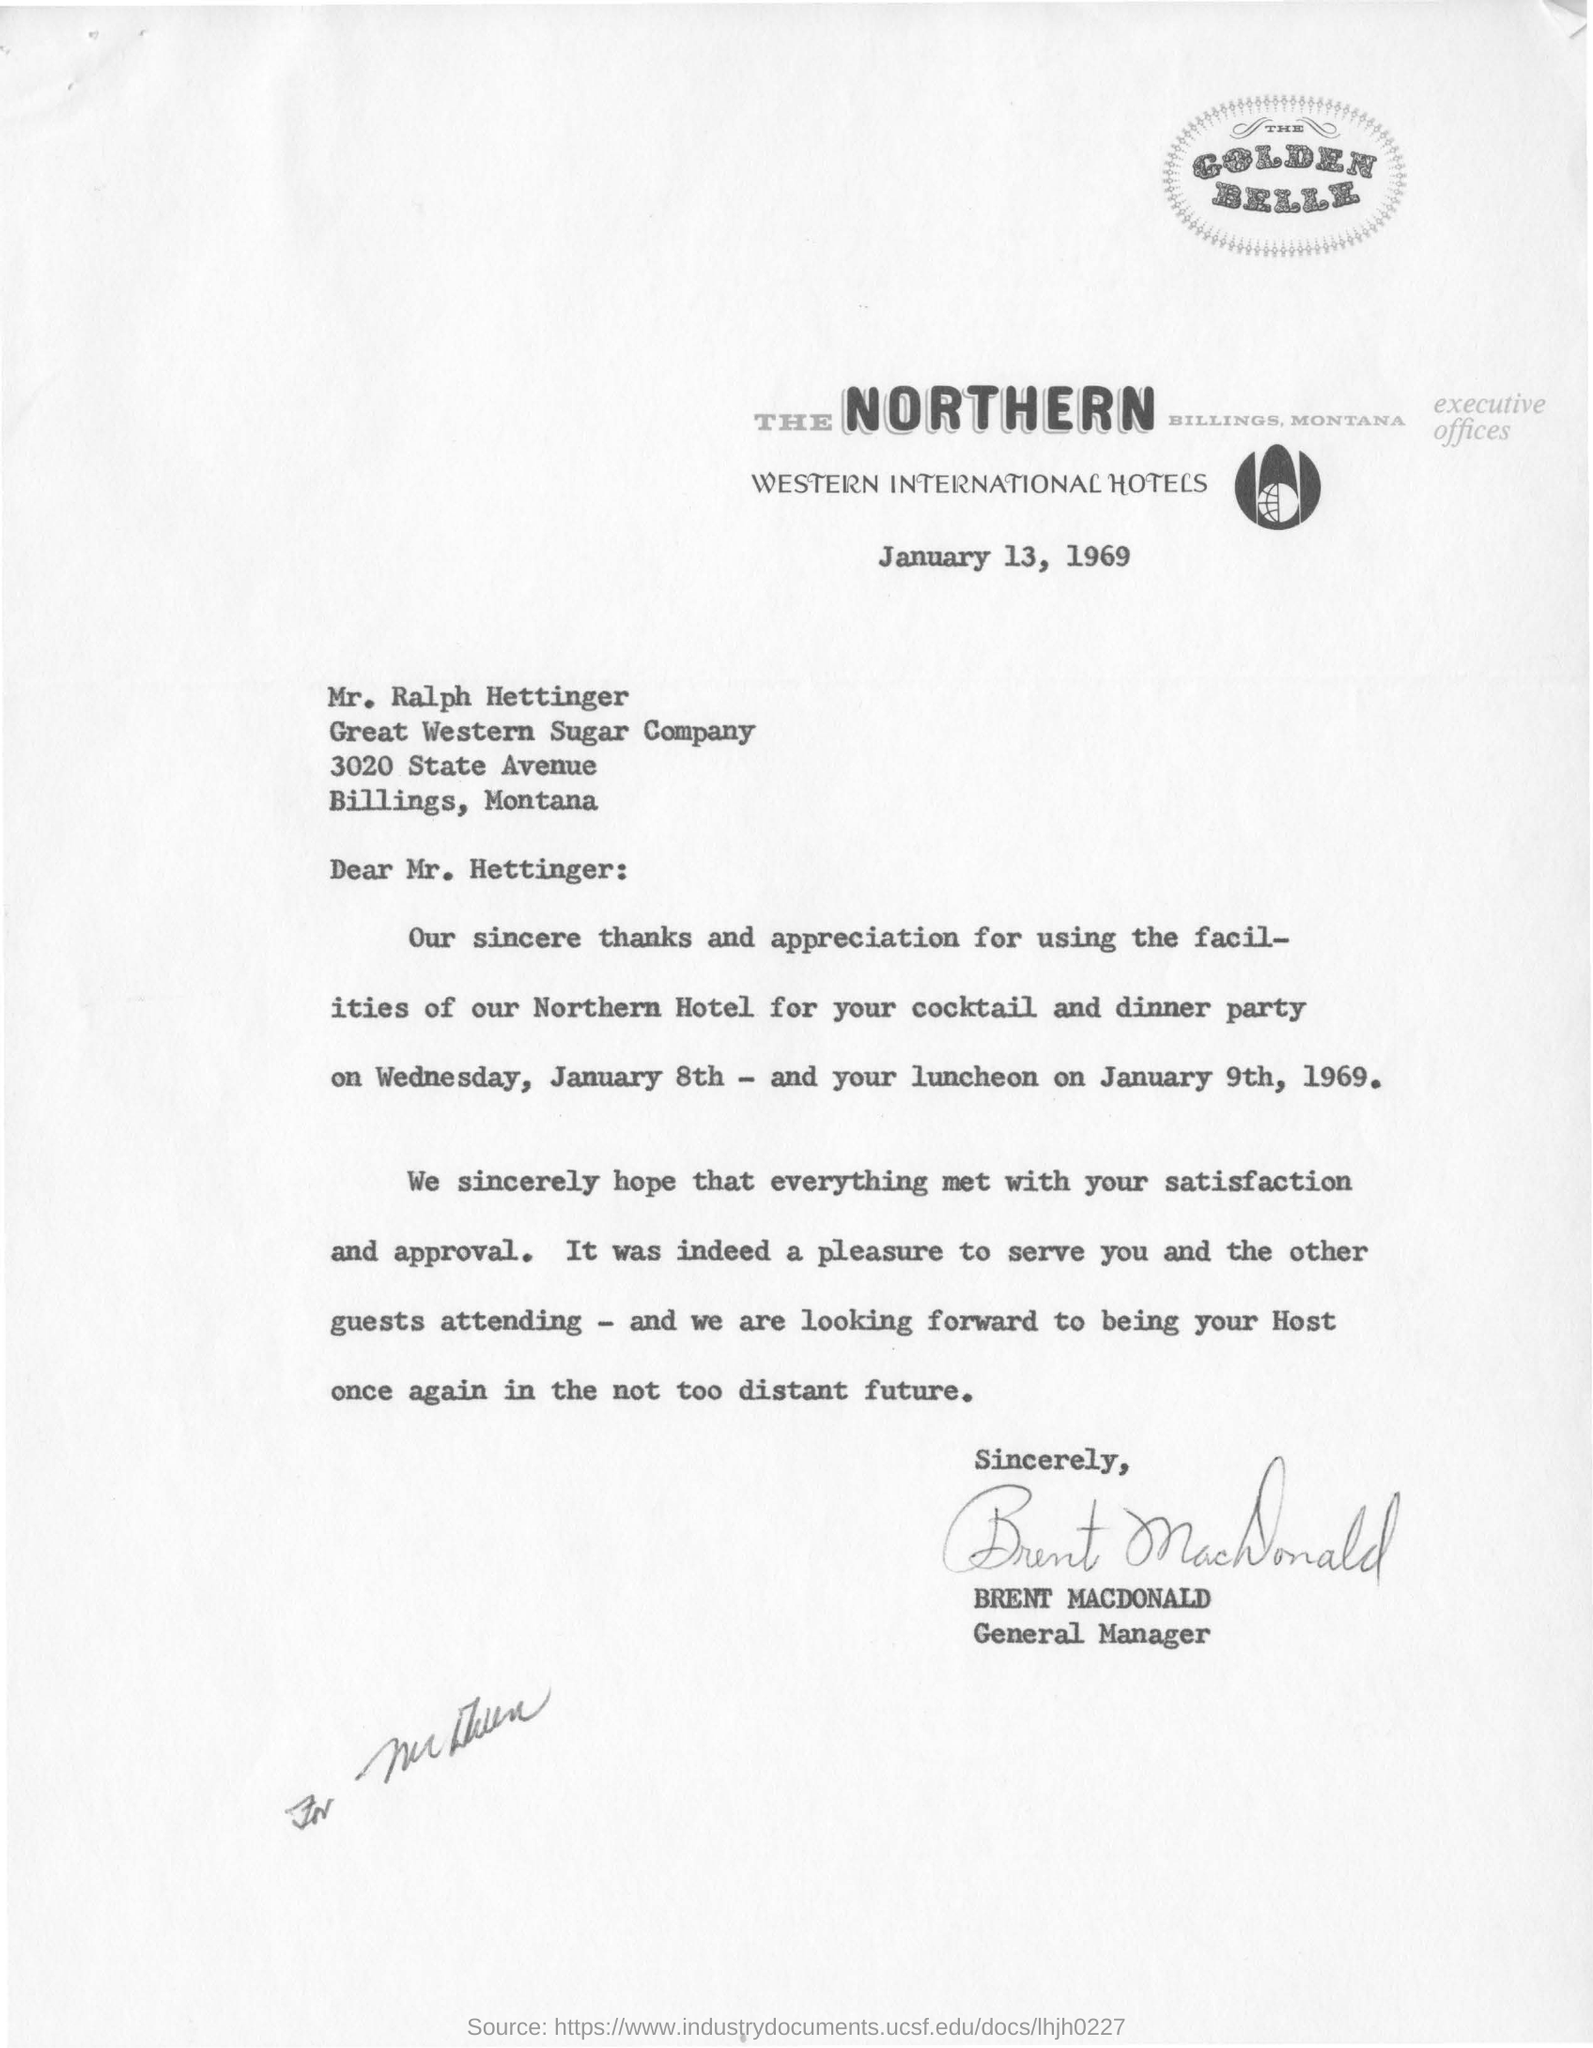To Whom is this letter addressed to?
Your answer should be very brief. Mr. Hettinger. On what date was the letter written?
Your answer should be very brief. January 13, 1969. Who is this letter from?
Give a very brief answer. BRENT MACDONALD. 